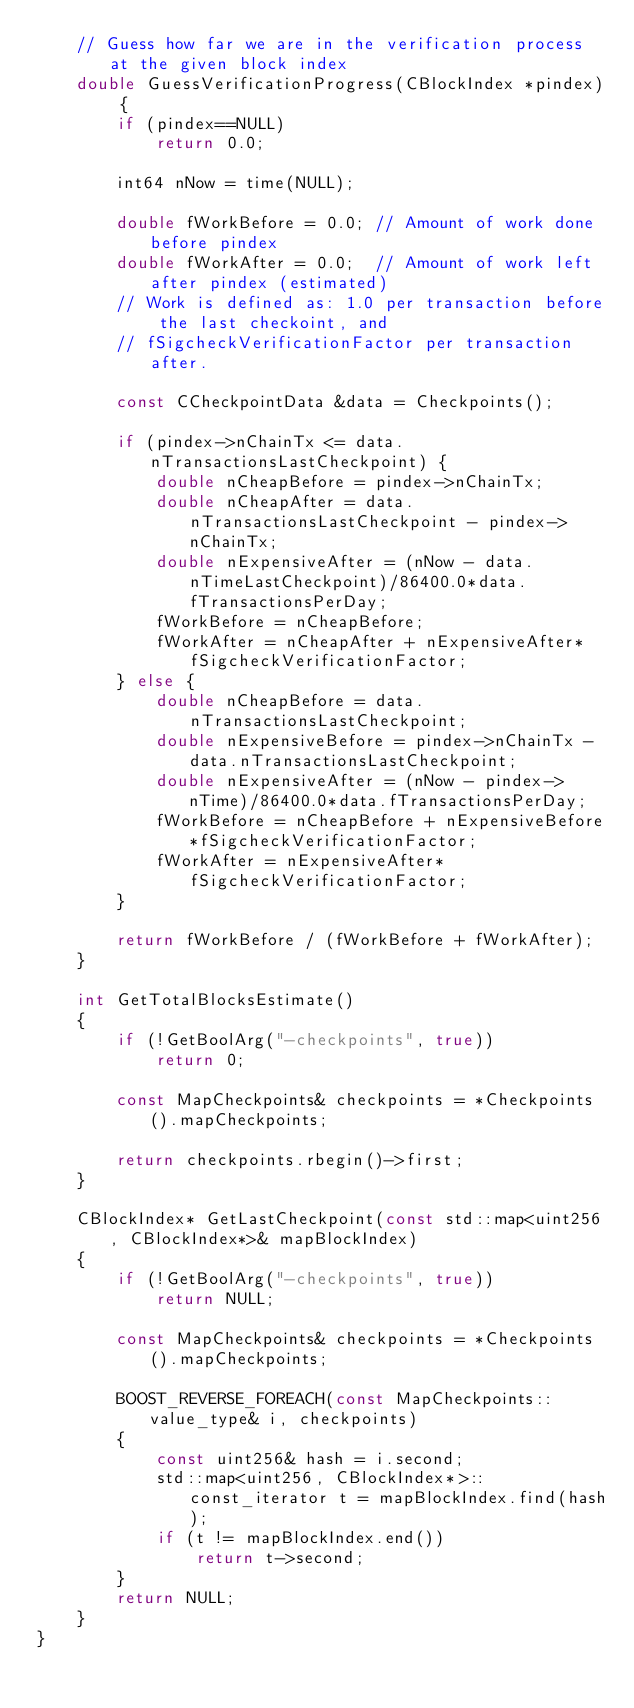<code> <loc_0><loc_0><loc_500><loc_500><_C++_>    // Guess how far we are in the verification process at the given block index
    double GuessVerificationProgress(CBlockIndex *pindex) {
        if (pindex==NULL)
            return 0.0;

        int64 nNow = time(NULL);

        double fWorkBefore = 0.0; // Amount of work done before pindex
        double fWorkAfter = 0.0;  // Amount of work left after pindex (estimated)
        // Work is defined as: 1.0 per transaction before the last checkoint, and
        // fSigcheckVerificationFactor per transaction after.

        const CCheckpointData &data = Checkpoints();

        if (pindex->nChainTx <= data.nTransactionsLastCheckpoint) {
            double nCheapBefore = pindex->nChainTx;
            double nCheapAfter = data.nTransactionsLastCheckpoint - pindex->nChainTx;
            double nExpensiveAfter = (nNow - data.nTimeLastCheckpoint)/86400.0*data.fTransactionsPerDay;
            fWorkBefore = nCheapBefore;
            fWorkAfter = nCheapAfter + nExpensiveAfter*fSigcheckVerificationFactor;
        } else {
            double nCheapBefore = data.nTransactionsLastCheckpoint;
            double nExpensiveBefore = pindex->nChainTx - data.nTransactionsLastCheckpoint;
            double nExpensiveAfter = (nNow - pindex->nTime)/86400.0*data.fTransactionsPerDay;
            fWorkBefore = nCheapBefore + nExpensiveBefore*fSigcheckVerificationFactor;
            fWorkAfter = nExpensiveAfter*fSigcheckVerificationFactor;
        }

        return fWorkBefore / (fWorkBefore + fWorkAfter);
    }

    int GetTotalBlocksEstimate()
    {
        if (!GetBoolArg("-checkpoints", true))
            return 0;

        const MapCheckpoints& checkpoints = *Checkpoints().mapCheckpoints;

        return checkpoints.rbegin()->first;
    }

    CBlockIndex* GetLastCheckpoint(const std::map<uint256, CBlockIndex*>& mapBlockIndex)
    {
        if (!GetBoolArg("-checkpoints", true))
            return NULL;

        const MapCheckpoints& checkpoints = *Checkpoints().mapCheckpoints;

        BOOST_REVERSE_FOREACH(const MapCheckpoints::value_type& i, checkpoints)
        {
            const uint256& hash = i.second;
            std::map<uint256, CBlockIndex*>::const_iterator t = mapBlockIndex.find(hash);
            if (t != mapBlockIndex.end())
                return t->second;
        }
        return NULL;
    }
}
</code> 